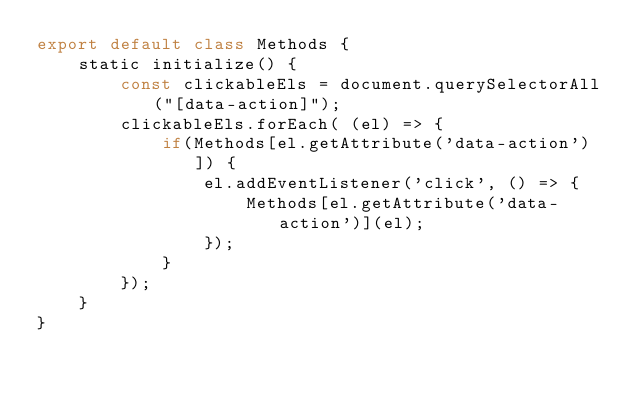<code> <loc_0><loc_0><loc_500><loc_500><_JavaScript_>export default class Methods {
    static initialize() {
        const clickableEls = document.querySelectorAll("[data-action]");
        clickableEls.forEach( (el) => {
            if(Methods[el.getAttribute('data-action')]) {
                el.addEventListener('click', () => {
                    Methods[el.getAttribute('data-action')](el);
                });
            }
        });
    }
}
</code> 